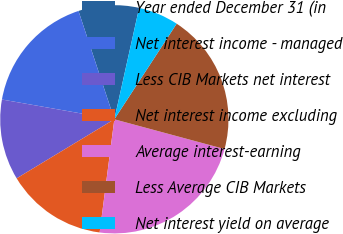Convert chart to OTSL. <chart><loc_0><loc_0><loc_500><loc_500><pie_chart><fcel>Year ended December 31 (in<fcel>Net interest income - managed<fcel>Less CIB Markets net interest<fcel>Net interest income excluding<fcel>Average interest-earning<fcel>Less Average CIB Markets<fcel>Net interest yield on average<nl><fcel>8.57%<fcel>17.14%<fcel>11.43%<fcel>14.29%<fcel>22.86%<fcel>20.0%<fcel>5.71%<nl></chart> 